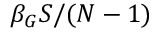<formula> <loc_0><loc_0><loc_500><loc_500>\beta _ { G } S / ( N - 1 )</formula> 